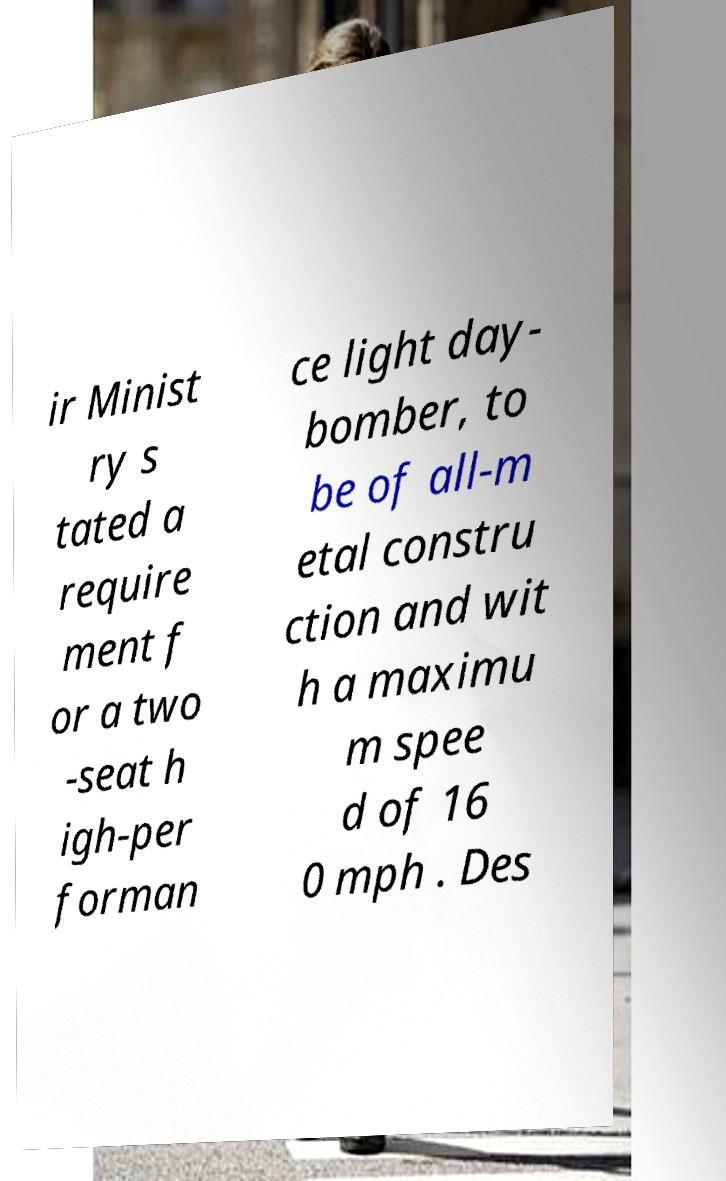Please identify and transcribe the text found in this image. ir Minist ry s tated a require ment f or a two -seat h igh-per forman ce light day- bomber, to be of all-m etal constru ction and wit h a maximu m spee d of 16 0 mph . Des 